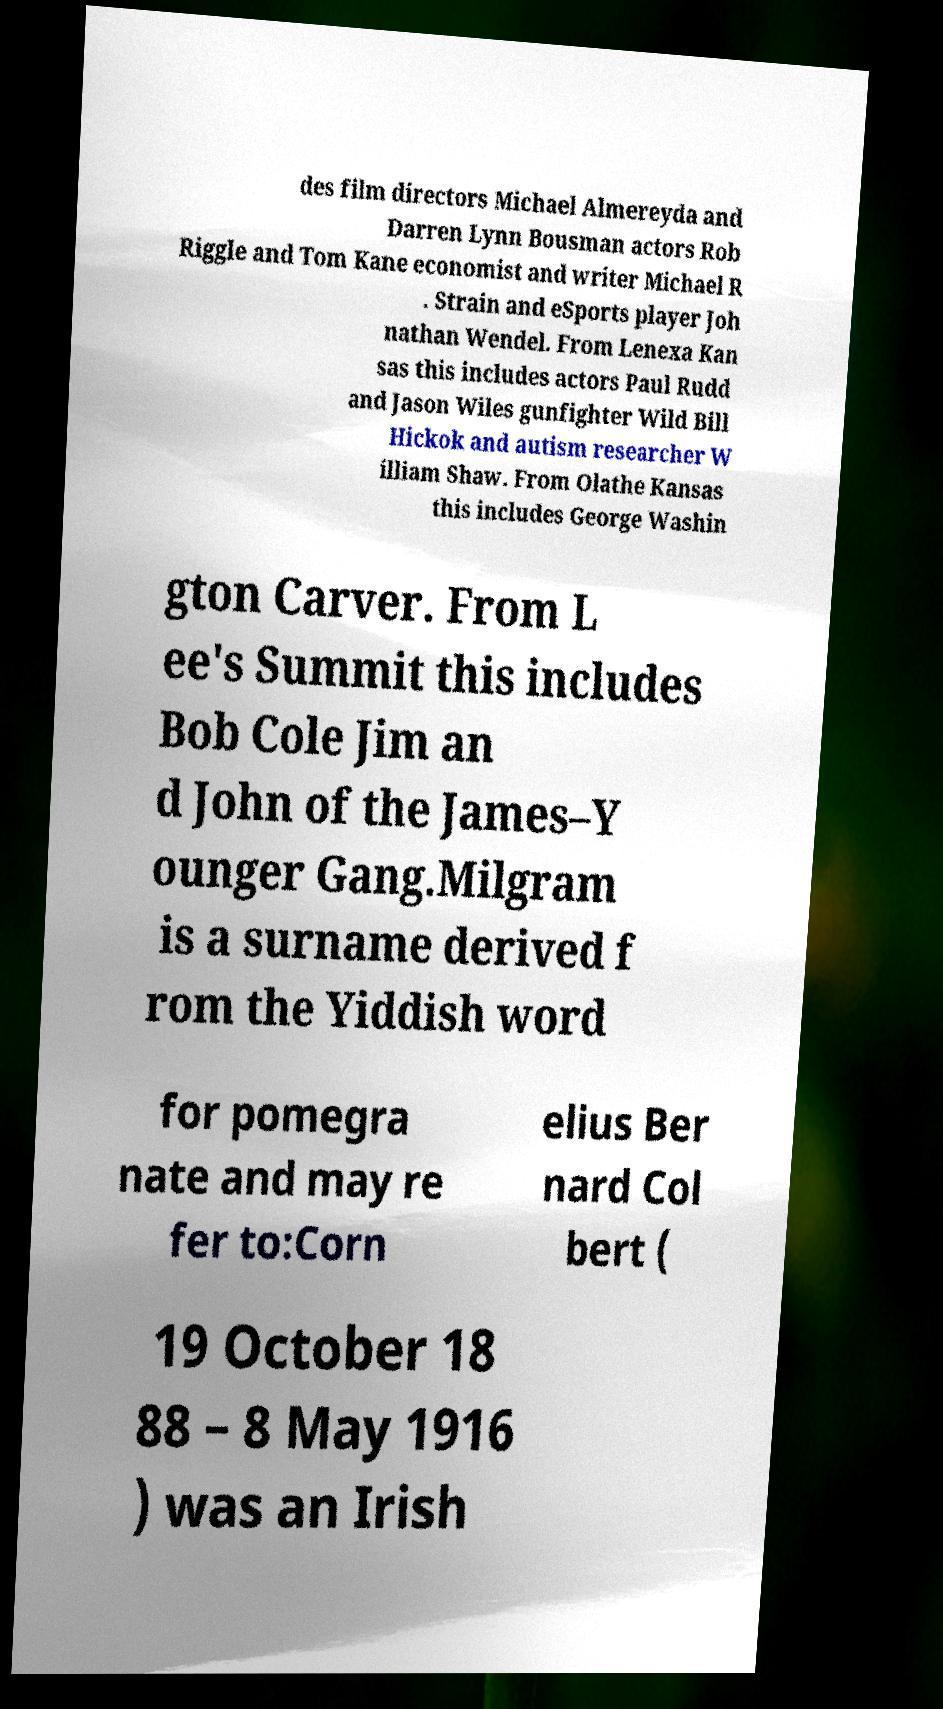Please read and relay the text visible in this image. What does it say? des film directors Michael Almereyda and Darren Lynn Bousman actors Rob Riggle and Tom Kane economist and writer Michael R . Strain and eSports player Joh nathan Wendel. From Lenexa Kan sas this includes actors Paul Rudd and Jason Wiles gunfighter Wild Bill Hickok and autism researcher W illiam Shaw. From Olathe Kansas this includes George Washin gton Carver. From L ee's Summit this includes Bob Cole Jim an d John of the James–Y ounger Gang.Milgram is a surname derived f rom the Yiddish word for pomegra nate and may re fer to:Corn elius Ber nard Col bert ( 19 October 18 88 – 8 May 1916 ) was an Irish 